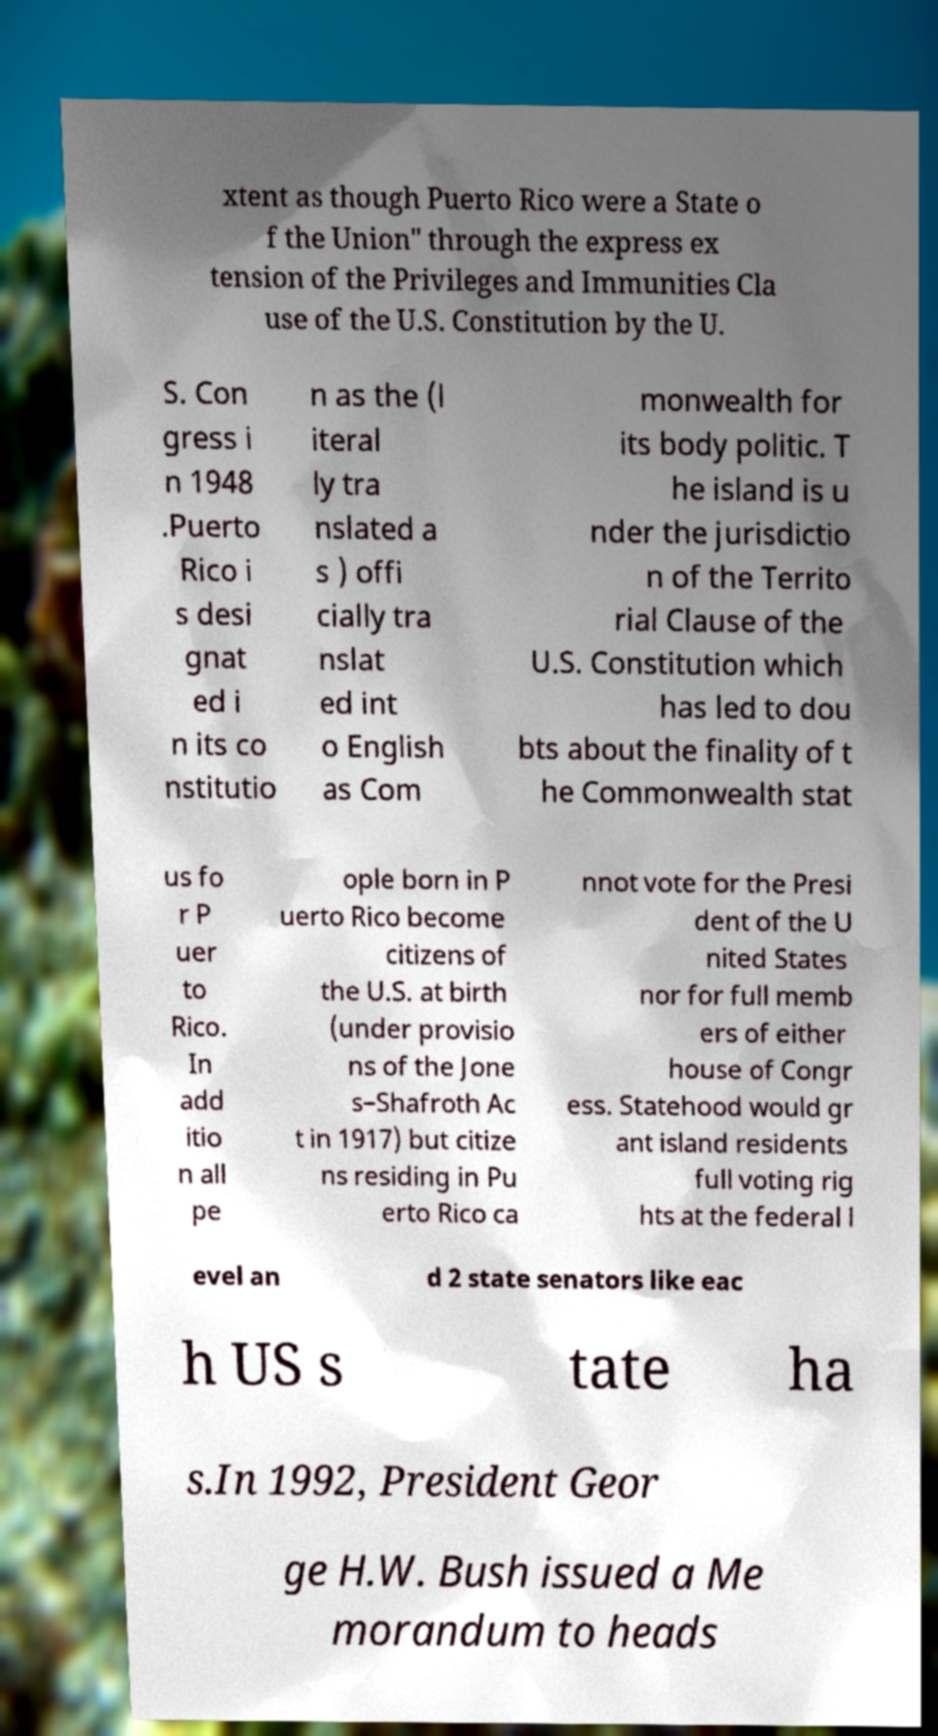Please identify and transcribe the text found in this image. xtent as though Puerto Rico were a State o f the Union" through the express ex tension of the Privileges and Immunities Cla use of the U.S. Constitution by the U. S. Con gress i n 1948 .Puerto Rico i s desi gnat ed i n its co nstitutio n as the (l iteral ly tra nslated a s ) offi cially tra nslat ed int o English as Com monwealth for its body politic. T he island is u nder the jurisdictio n of the Territo rial Clause of the U.S. Constitution which has led to dou bts about the finality of t he Commonwealth stat us fo r P uer to Rico. In add itio n all pe ople born in P uerto Rico become citizens of the U.S. at birth (under provisio ns of the Jone s–Shafroth Ac t in 1917) but citize ns residing in Pu erto Rico ca nnot vote for the Presi dent of the U nited States nor for full memb ers of either house of Congr ess. Statehood would gr ant island residents full voting rig hts at the federal l evel an d 2 state senators like eac h US s tate ha s.In 1992, President Geor ge H.W. Bush issued a Me morandum to heads 